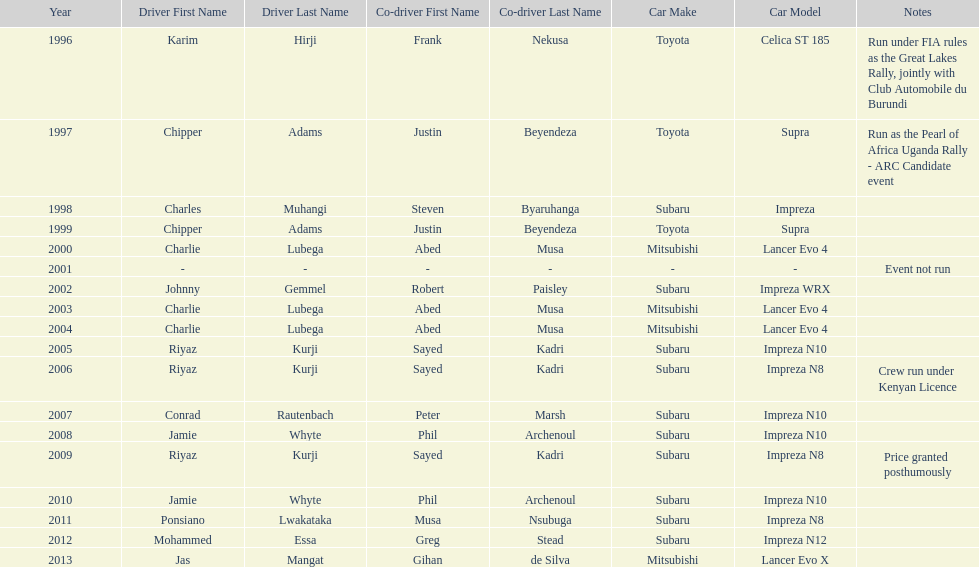How many times was a mitsubishi lancer the winning car before the year 2004? 2. Could you parse the entire table as a dict? {'header': ['Year', 'Driver First Name', 'Driver Last Name', 'Co-driver First Name', 'Co-driver Last Name', 'Car Make', 'Car Model', 'Notes'], 'rows': [['1996', 'Karim', 'Hirji', 'Frank', 'Nekusa', 'Toyota', 'Celica ST 185', 'Run under FIA rules as the Great Lakes Rally, jointly with Club Automobile du Burundi'], ['1997', 'Chipper', 'Adams', 'Justin', 'Beyendeza', 'Toyota', 'Supra', 'Run as the Pearl of Africa Uganda Rally - ARC Candidate event'], ['1998', 'Charles', 'Muhangi', 'Steven', 'Byaruhanga', 'Subaru', 'Impreza', ''], ['1999', 'Chipper', 'Adams', 'Justin', 'Beyendeza', 'Toyota', 'Supra', ''], ['2000', 'Charlie', 'Lubega', 'Abed', 'Musa', 'Mitsubishi', 'Lancer Evo 4', ''], ['2001', '-', '-', '-', '-', '-', '-', 'Event not run'], ['2002', 'Johnny', 'Gemmel', 'Robert', 'Paisley', 'Subaru', 'Impreza WRX', ''], ['2003', 'Charlie', 'Lubega', 'Abed', 'Musa', 'Mitsubishi', 'Lancer Evo 4', ''], ['2004', 'Charlie', 'Lubega', 'Abed', 'Musa', 'Mitsubishi', 'Lancer Evo 4', ''], ['2005', 'Riyaz', 'Kurji', 'Sayed', 'Kadri', 'Subaru', 'Impreza N10', ''], ['2006', 'Riyaz', 'Kurji', 'Sayed', 'Kadri', 'Subaru', 'Impreza N8', 'Crew run under Kenyan Licence'], ['2007', 'Conrad', 'Rautenbach', 'Peter', 'Marsh', 'Subaru', 'Impreza N10', ''], ['2008', 'Jamie', 'Whyte', 'Phil', 'Archenoul', 'Subaru', 'Impreza N10', ''], ['2009', 'Riyaz', 'Kurji', 'Sayed', 'Kadri', 'Subaru', 'Impreza N8', 'Price granted posthumously'], ['2010', 'Jamie', 'Whyte', 'Phil', 'Archenoul', 'Subaru', 'Impreza N10', ''], ['2011', 'Ponsiano', 'Lwakataka', 'Musa', 'Nsubuga', 'Subaru', 'Impreza N8', ''], ['2012', 'Mohammed', 'Essa', 'Greg', 'Stead', 'Subaru', 'Impreza N12', ''], ['2013', 'Jas', 'Mangat', 'Gihan', 'de Silva', 'Mitsubishi', 'Lancer Evo X', '']]} 